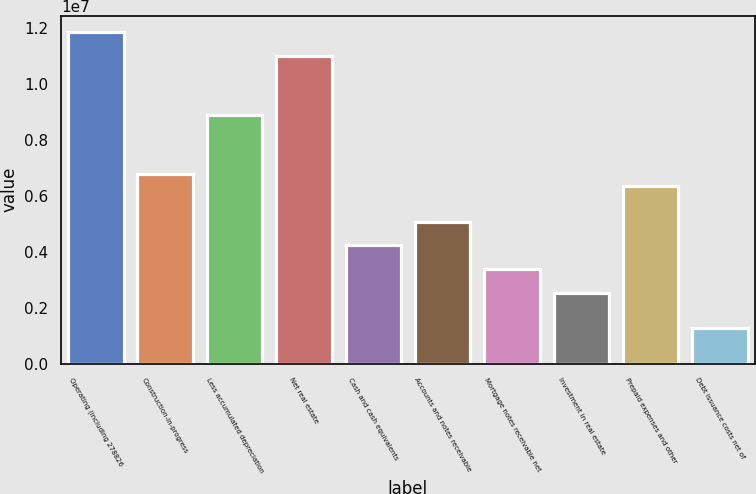<chart> <loc_0><loc_0><loc_500><loc_500><bar_chart><fcel>Operating (including 278826<fcel>Construction-in-progress<fcel>Less accumulated depreciation<fcel>Net real estate<fcel>Cash and cash equivalents<fcel>Accounts and notes receivable<fcel>Mortgage notes receivable net<fcel>Investment in real estate<fcel>Prepaid expenses and other<fcel>Debt issuance costs net of<nl><fcel>1.18502e+07<fcel>6.77179e+06<fcel>8.88778e+06<fcel>1.10038e+07<fcel>4.23261e+06<fcel>5.079e+06<fcel>3.38621e+06<fcel>2.53982e+06<fcel>6.34859e+06<fcel>1.27023e+06<nl></chart> 